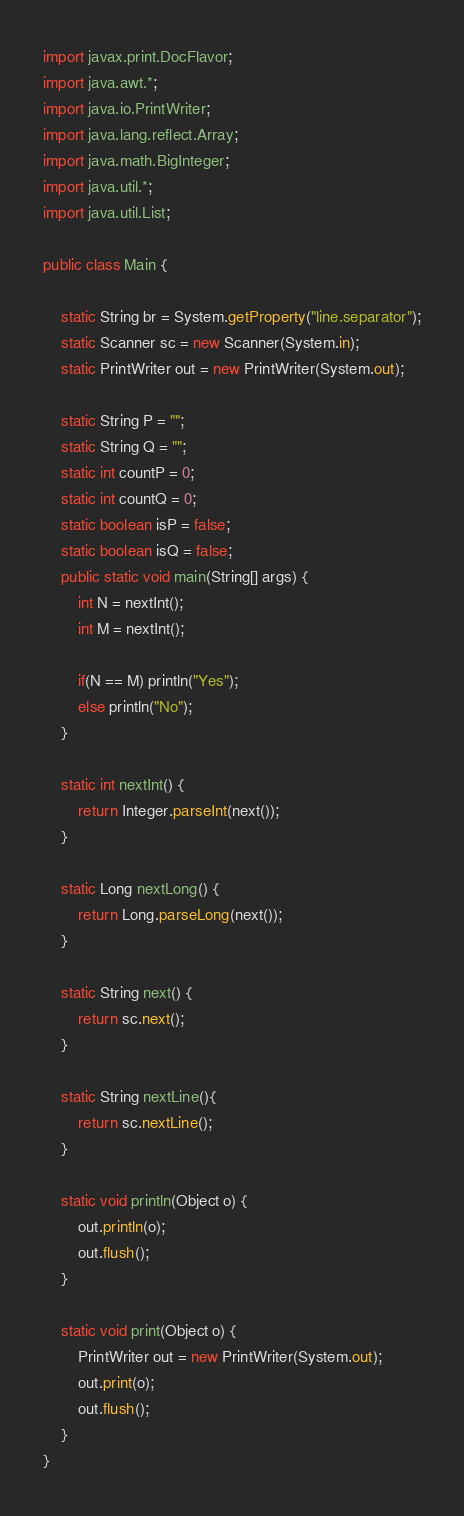Convert code to text. <code><loc_0><loc_0><loc_500><loc_500><_Java_>import javax.print.DocFlavor;
import java.awt.*;
import java.io.PrintWriter;
import java.lang.reflect.Array;
import java.math.BigInteger;
import java.util.*;
import java.util.List;

public class Main {

    static String br = System.getProperty("line.separator");
    static Scanner sc = new Scanner(System.in);
    static PrintWriter out = new PrintWriter(System.out);

    static String P = "";
    static String Q = "";
    static int countP = 0;
    static int countQ = 0;
    static boolean isP = false;
    static boolean isQ = false;
    public static void main(String[] args) {
        int N = nextInt();
        int M = nextInt();

        if(N == M) println("Yes");
        else println("No");
    }

    static int nextInt() {
        return Integer.parseInt(next());
    }

    static Long nextLong() {
        return Long.parseLong(next());
    }

    static String next() {
        return sc.next();
    }

    static String nextLine(){
        return sc.nextLine();
    }

    static void println(Object o) {
        out.println(o);
        out.flush();
    }

    static void print(Object o) {
        PrintWriter out = new PrintWriter(System.out);
        out.print(o);
        out.flush();
    }
}
</code> 